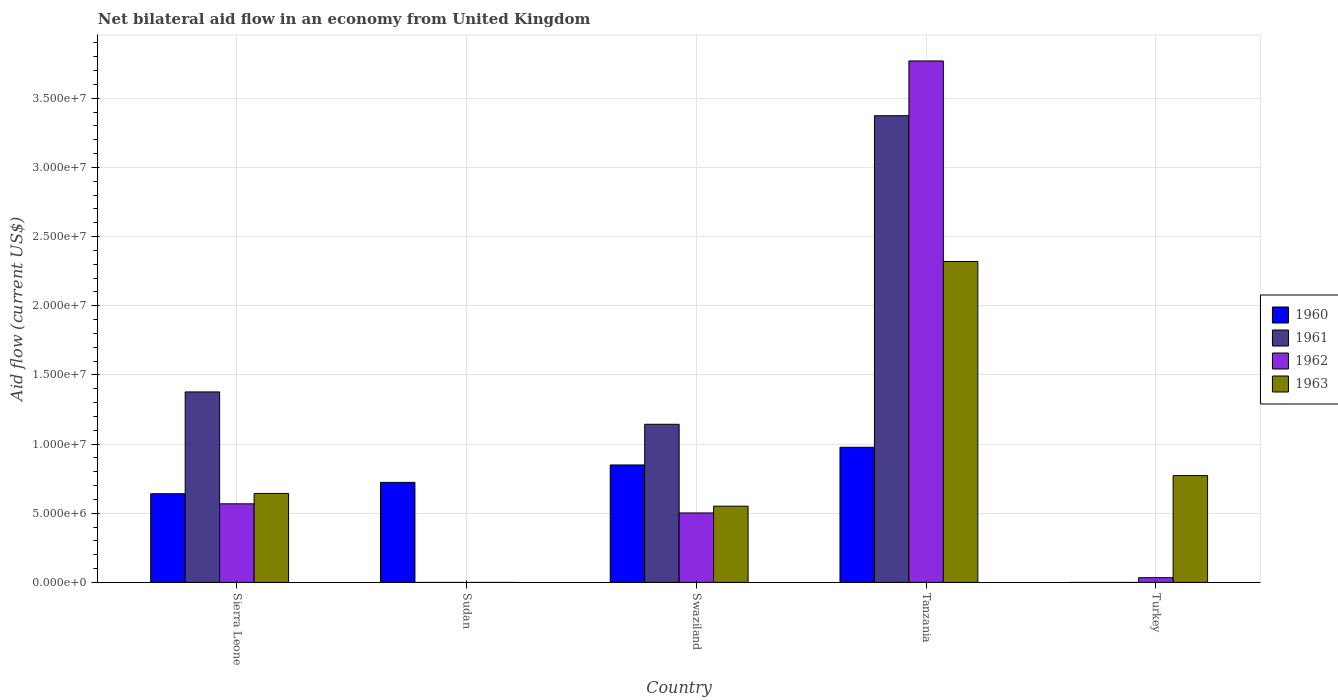How many different coloured bars are there?
Provide a short and direct response. 4. Are the number of bars per tick equal to the number of legend labels?
Keep it short and to the point. No. What is the label of the 1st group of bars from the left?
Your response must be concise. Sierra Leone. In how many cases, is the number of bars for a given country not equal to the number of legend labels?
Provide a succinct answer. 2. What is the net bilateral aid flow in 1962 in Sierra Leone?
Offer a very short reply. 5.68e+06. Across all countries, what is the maximum net bilateral aid flow in 1961?
Keep it short and to the point. 3.37e+07. In which country was the net bilateral aid flow in 1962 maximum?
Offer a very short reply. Tanzania. What is the total net bilateral aid flow in 1961 in the graph?
Your answer should be compact. 5.89e+07. What is the difference between the net bilateral aid flow in 1960 in Sierra Leone and that in Tanzania?
Make the answer very short. -3.36e+06. What is the difference between the net bilateral aid flow in 1960 in Sudan and the net bilateral aid flow in 1963 in Turkey?
Offer a terse response. -4.90e+05. What is the average net bilateral aid flow in 1960 per country?
Provide a succinct answer. 6.38e+06. What is the difference between the net bilateral aid flow of/in 1960 and net bilateral aid flow of/in 1962 in Tanzania?
Offer a terse response. -2.79e+07. In how many countries, is the net bilateral aid flow in 1960 greater than 37000000 US$?
Your response must be concise. 0. What is the ratio of the net bilateral aid flow in 1963 in Swaziland to that in Turkey?
Your response must be concise. 0.71. What is the difference between the highest and the second highest net bilateral aid flow in 1963?
Your answer should be compact. 1.68e+07. What is the difference between the highest and the lowest net bilateral aid flow in 1963?
Your response must be concise. 2.32e+07. Is the sum of the net bilateral aid flow in 1963 in Swaziland and Turkey greater than the maximum net bilateral aid flow in 1961 across all countries?
Offer a very short reply. No. How many bars are there?
Your answer should be very brief. 15. How many countries are there in the graph?
Your answer should be very brief. 5. What is the difference between two consecutive major ticks on the Y-axis?
Your response must be concise. 5.00e+06. Does the graph contain any zero values?
Keep it short and to the point. Yes. Does the graph contain grids?
Provide a succinct answer. Yes. Where does the legend appear in the graph?
Offer a very short reply. Center right. What is the title of the graph?
Your answer should be very brief. Net bilateral aid flow in an economy from United Kingdom. What is the Aid flow (current US$) of 1960 in Sierra Leone?
Provide a succinct answer. 6.41e+06. What is the Aid flow (current US$) of 1961 in Sierra Leone?
Offer a terse response. 1.38e+07. What is the Aid flow (current US$) of 1962 in Sierra Leone?
Make the answer very short. 5.68e+06. What is the Aid flow (current US$) in 1963 in Sierra Leone?
Keep it short and to the point. 6.43e+06. What is the Aid flow (current US$) in 1960 in Sudan?
Provide a short and direct response. 7.23e+06. What is the Aid flow (current US$) of 1961 in Sudan?
Provide a short and direct response. 0. What is the Aid flow (current US$) of 1963 in Sudan?
Make the answer very short. 0. What is the Aid flow (current US$) of 1960 in Swaziland?
Offer a very short reply. 8.49e+06. What is the Aid flow (current US$) of 1961 in Swaziland?
Your response must be concise. 1.14e+07. What is the Aid flow (current US$) of 1962 in Swaziland?
Provide a succinct answer. 5.02e+06. What is the Aid flow (current US$) in 1963 in Swaziland?
Give a very brief answer. 5.51e+06. What is the Aid flow (current US$) in 1960 in Tanzania?
Make the answer very short. 9.77e+06. What is the Aid flow (current US$) in 1961 in Tanzania?
Offer a terse response. 3.37e+07. What is the Aid flow (current US$) in 1962 in Tanzania?
Keep it short and to the point. 3.77e+07. What is the Aid flow (current US$) of 1963 in Tanzania?
Give a very brief answer. 2.32e+07. What is the Aid flow (current US$) of 1960 in Turkey?
Give a very brief answer. 0. What is the Aid flow (current US$) of 1961 in Turkey?
Provide a short and direct response. 0. What is the Aid flow (current US$) in 1962 in Turkey?
Keep it short and to the point. 3.40e+05. What is the Aid flow (current US$) in 1963 in Turkey?
Offer a very short reply. 7.72e+06. Across all countries, what is the maximum Aid flow (current US$) of 1960?
Give a very brief answer. 9.77e+06. Across all countries, what is the maximum Aid flow (current US$) of 1961?
Your response must be concise. 3.37e+07. Across all countries, what is the maximum Aid flow (current US$) of 1962?
Your response must be concise. 3.77e+07. Across all countries, what is the maximum Aid flow (current US$) in 1963?
Make the answer very short. 2.32e+07. Across all countries, what is the minimum Aid flow (current US$) of 1960?
Provide a succinct answer. 0. Across all countries, what is the minimum Aid flow (current US$) of 1961?
Your answer should be compact. 0. Across all countries, what is the minimum Aid flow (current US$) in 1962?
Provide a succinct answer. 0. Across all countries, what is the minimum Aid flow (current US$) in 1963?
Offer a very short reply. 0. What is the total Aid flow (current US$) in 1960 in the graph?
Ensure brevity in your answer.  3.19e+07. What is the total Aid flow (current US$) in 1961 in the graph?
Your answer should be compact. 5.89e+07. What is the total Aid flow (current US$) in 1962 in the graph?
Provide a succinct answer. 4.87e+07. What is the total Aid flow (current US$) in 1963 in the graph?
Offer a terse response. 4.29e+07. What is the difference between the Aid flow (current US$) of 1960 in Sierra Leone and that in Sudan?
Give a very brief answer. -8.20e+05. What is the difference between the Aid flow (current US$) of 1960 in Sierra Leone and that in Swaziland?
Offer a terse response. -2.08e+06. What is the difference between the Aid flow (current US$) of 1961 in Sierra Leone and that in Swaziland?
Your response must be concise. 2.34e+06. What is the difference between the Aid flow (current US$) in 1963 in Sierra Leone and that in Swaziland?
Keep it short and to the point. 9.20e+05. What is the difference between the Aid flow (current US$) of 1960 in Sierra Leone and that in Tanzania?
Offer a very short reply. -3.36e+06. What is the difference between the Aid flow (current US$) of 1961 in Sierra Leone and that in Tanzania?
Your answer should be very brief. -2.00e+07. What is the difference between the Aid flow (current US$) of 1962 in Sierra Leone and that in Tanzania?
Give a very brief answer. -3.20e+07. What is the difference between the Aid flow (current US$) of 1963 in Sierra Leone and that in Tanzania?
Provide a succinct answer. -1.68e+07. What is the difference between the Aid flow (current US$) in 1962 in Sierra Leone and that in Turkey?
Your answer should be very brief. 5.34e+06. What is the difference between the Aid flow (current US$) in 1963 in Sierra Leone and that in Turkey?
Your answer should be very brief. -1.29e+06. What is the difference between the Aid flow (current US$) of 1960 in Sudan and that in Swaziland?
Your response must be concise. -1.26e+06. What is the difference between the Aid flow (current US$) in 1960 in Sudan and that in Tanzania?
Your answer should be compact. -2.54e+06. What is the difference between the Aid flow (current US$) in 1960 in Swaziland and that in Tanzania?
Make the answer very short. -1.28e+06. What is the difference between the Aid flow (current US$) in 1961 in Swaziland and that in Tanzania?
Keep it short and to the point. -2.23e+07. What is the difference between the Aid flow (current US$) of 1962 in Swaziland and that in Tanzania?
Give a very brief answer. -3.27e+07. What is the difference between the Aid flow (current US$) in 1963 in Swaziland and that in Tanzania?
Provide a short and direct response. -1.77e+07. What is the difference between the Aid flow (current US$) of 1962 in Swaziland and that in Turkey?
Offer a very short reply. 4.68e+06. What is the difference between the Aid flow (current US$) in 1963 in Swaziland and that in Turkey?
Ensure brevity in your answer.  -2.21e+06. What is the difference between the Aid flow (current US$) in 1962 in Tanzania and that in Turkey?
Keep it short and to the point. 3.74e+07. What is the difference between the Aid flow (current US$) in 1963 in Tanzania and that in Turkey?
Your answer should be very brief. 1.55e+07. What is the difference between the Aid flow (current US$) in 1960 in Sierra Leone and the Aid flow (current US$) in 1961 in Swaziland?
Offer a very short reply. -5.02e+06. What is the difference between the Aid flow (current US$) in 1960 in Sierra Leone and the Aid flow (current US$) in 1962 in Swaziland?
Give a very brief answer. 1.39e+06. What is the difference between the Aid flow (current US$) in 1960 in Sierra Leone and the Aid flow (current US$) in 1963 in Swaziland?
Keep it short and to the point. 9.00e+05. What is the difference between the Aid flow (current US$) of 1961 in Sierra Leone and the Aid flow (current US$) of 1962 in Swaziland?
Provide a succinct answer. 8.75e+06. What is the difference between the Aid flow (current US$) in 1961 in Sierra Leone and the Aid flow (current US$) in 1963 in Swaziland?
Give a very brief answer. 8.26e+06. What is the difference between the Aid flow (current US$) in 1962 in Sierra Leone and the Aid flow (current US$) in 1963 in Swaziland?
Offer a terse response. 1.70e+05. What is the difference between the Aid flow (current US$) of 1960 in Sierra Leone and the Aid flow (current US$) of 1961 in Tanzania?
Your answer should be compact. -2.73e+07. What is the difference between the Aid flow (current US$) in 1960 in Sierra Leone and the Aid flow (current US$) in 1962 in Tanzania?
Make the answer very short. -3.13e+07. What is the difference between the Aid flow (current US$) in 1960 in Sierra Leone and the Aid flow (current US$) in 1963 in Tanzania?
Offer a terse response. -1.68e+07. What is the difference between the Aid flow (current US$) in 1961 in Sierra Leone and the Aid flow (current US$) in 1962 in Tanzania?
Give a very brief answer. -2.39e+07. What is the difference between the Aid flow (current US$) of 1961 in Sierra Leone and the Aid flow (current US$) of 1963 in Tanzania?
Your answer should be compact. -9.43e+06. What is the difference between the Aid flow (current US$) in 1962 in Sierra Leone and the Aid flow (current US$) in 1963 in Tanzania?
Your answer should be very brief. -1.75e+07. What is the difference between the Aid flow (current US$) in 1960 in Sierra Leone and the Aid flow (current US$) in 1962 in Turkey?
Keep it short and to the point. 6.07e+06. What is the difference between the Aid flow (current US$) of 1960 in Sierra Leone and the Aid flow (current US$) of 1963 in Turkey?
Keep it short and to the point. -1.31e+06. What is the difference between the Aid flow (current US$) in 1961 in Sierra Leone and the Aid flow (current US$) in 1962 in Turkey?
Your response must be concise. 1.34e+07. What is the difference between the Aid flow (current US$) in 1961 in Sierra Leone and the Aid flow (current US$) in 1963 in Turkey?
Offer a terse response. 6.05e+06. What is the difference between the Aid flow (current US$) in 1962 in Sierra Leone and the Aid flow (current US$) in 1963 in Turkey?
Give a very brief answer. -2.04e+06. What is the difference between the Aid flow (current US$) in 1960 in Sudan and the Aid flow (current US$) in 1961 in Swaziland?
Provide a short and direct response. -4.20e+06. What is the difference between the Aid flow (current US$) in 1960 in Sudan and the Aid flow (current US$) in 1962 in Swaziland?
Your response must be concise. 2.21e+06. What is the difference between the Aid flow (current US$) of 1960 in Sudan and the Aid flow (current US$) of 1963 in Swaziland?
Your response must be concise. 1.72e+06. What is the difference between the Aid flow (current US$) of 1960 in Sudan and the Aid flow (current US$) of 1961 in Tanzania?
Provide a short and direct response. -2.65e+07. What is the difference between the Aid flow (current US$) of 1960 in Sudan and the Aid flow (current US$) of 1962 in Tanzania?
Your answer should be compact. -3.05e+07. What is the difference between the Aid flow (current US$) of 1960 in Sudan and the Aid flow (current US$) of 1963 in Tanzania?
Give a very brief answer. -1.60e+07. What is the difference between the Aid flow (current US$) in 1960 in Sudan and the Aid flow (current US$) in 1962 in Turkey?
Offer a terse response. 6.89e+06. What is the difference between the Aid flow (current US$) in 1960 in Sudan and the Aid flow (current US$) in 1963 in Turkey?
Provide a succinct answer. -4.90e+05. What is the difference between the Aid flow (current US$) of 1960 in Swaziland and the Aid flow (current US$) of 1961 in Tanzania?
Offer a very short reply. -2.52e+07. What is the difference between the Aid flow (current US$) in 1960 in Swaziland and the Aid flow (current US$) in 1962 in Tanzania?
Make the answer very short. -2.92e+07. What is the difference between the Aid flow (current US$) of 1960 in Swaziland and the Aid flow (current US$) of 1963 in Tanzania?
Your answer should be compact. -1.47e+07. What is the difference between the Aid flow (current US$) in 1961 in Swaziland and the Aid flow (current US$) in 1962 in Tanzania?
Your answer should be very brief. -2.63e+07. What is the difference between the Aid flow (current US$) of 1961 in Swaziland and the Aid flow (current US$) of 1963 in Tanzania?
Ensure brevity in your answer.  -1.18e+07. What is the difference between the Aid flow (current US$) in 1962 in Swaziland and the Aid flow (current US$) in 1963 in Tanzania?
Your answer should be very brief. -1.82e+07. What is the difference between the Aid flow (current US$) in 1960 in Swaziland and the Aid flow (current US$) in 1962 in Turkey?
Your answer should be very brief. 8.15e+06. What is the difference between the Aid flow (current US$) in 1960 in Swaziland and the Aid flow (current US$) in 1963 in Turkey?
Give a very brief answer. 7.70e+05. What is the difference between the Aid flow (current US$) of 1961 in Swaziland and the Aid flow (current US$) of 1962 in Turkey?
Your response must be concise. 1.11e+07. What is the difference between the Aid flow (current US$) in 1961 in Swaziland and the Aid flow (current US$) in 1963 in Turkey?
Keep it short and to the point. 3.71e+06. What is the difference between the Aid flow (current US$) in 1962 in Swaziland and the Aid flow (current US$) in 1963 in Turkey?
Make the answer very short. -2.70e+06. What is the difference between the Aid flow (current US$) in 1960 in Tanzania and the Aid flow (current US$) in 1962 in Turkey?
Provide a succinct answer. 9.43e+06. What is the difference between the Aid flow (current US$) of 1960 in Tanzania and the Aid flow (current US$) of 1963 in Turkey?
Give a very brief answer. 2.05e+06. What is the difference between the Aid flow (current US$) in 1961 in Tanzania and the Aid flow (current US$) in 1962 in Turkey?
Your answer should be very brief. 3.34e+07. What is the difference between the Aid flow (current US$) of 1961 in Tanzania and the Aid flow (current US$) of 1963 in Turkey?
Keep it short and to the point. 2.60e+07. What is the difference between the Aid flow (current US$) in 1962 in Tanzania and the Aid flow (current US$) in 1963 in Turkey?
Your response must be concise. 3.00e+07. What is the average Aid flow (current US$) of 1960 per country?
Your response must be concise. 6.38e+06. What is the average Aid flow (current US$) in 1961 per country?
Your answer should be compact. 1.18e+07. What is the average Aid flow (current US$) in 1962 per country?
Offer a terse response. 9.75e+06. What is the average Aid flow (current US$) in 1963 per country?
Your answer should be compact. 8.57e+06. What is the difference between the Aid flow (current US$) of 1960 and Aid flow (current US$) of 1961 in Sierra Leone?
Make the answer very short. -7.36e+06. What is the difference between the Aid flow (current US$) of 1960 and Aid flow (current US$) of 1962 in Sierra Leone?
Give a very brief answer. 7.30e+05. What is the difference between the Aid flow (current US$) of 1961 and Aid flow (current US$) of 1962 in Sierra Leone?
Your answer should be compact. 8.09e+06. What is the difference between the Aid flow (current US$) in 1961 and Aid flow (current US$) in 1963 in Sierra Leone?
Make the answer very short. 7.34e+06. What is the difference between the Aid flow (current US$) in 1962 and Aid flow (current US$) in 1963 in Sierra Leone?
Offer a very short reply. -7.50e+05. What is the difference between the Aid flow (current US$) in 1960 and Aid flow (current US$) in 1961 in Swaziland?
Your answer should be compact. -2.94e+06. What is the difference between the Aid flow (current US$) of 1960 and Aid flow (current US$) of 1962 in Swaziland?
Make the answer very short. 3.47e+06. What is the difference between the Aid flow (current US$) in 1960 and Aid flow (current US$) in 1963 in Swaziland?
Give a very brief answer. 2.98e+06. What is the difference between the Aid flow (current US$) of 1961 and Aid flow (current US$) of 1962 in Swaziland?
Provide a short and direct response. 6.41e+06. What is the difference between the Aid flow (current US$) in 1961 and Aid flow (current US$) in 1963 in Swaziland?
Ensure brevity in your answer.  5.92e+06. What is the difference between the Aid flow (current US$) in 1962 and Aid flow (current US$) in 1963 in Swaziland?
Give a very brief answer. -4.90e+05. What is the difference between the Aid flow (current US$) of 1960 and Aid flow (current US$) of 1961 in Tanzania?
Your answer should be very brief. -2.40e+07. What is the difference between the Aid flow (current US$) in 1960 and Aid flow (current US$) in 1962 in Tanzania?
Your response must be concise. -2.79e+07. What is the difference between the Aid flow (current US$) in 1960 and Aid flow (current US$) in 1963 in Tanzania?
Make the answer very short. -1.34e+07. What is the difference between the Aid flow (current US$) in 1961 and Aid flow (current US$) in 1962 in Tanzania?
Give a very brief answer. -3.96e+06. What is the difference between the Aid flow (current US$) in 1961 and Aid flow (current US$) in 1963 in Tanzania?
Your answer should be very brief. 1.05e+07. What is the difference between the Aid flow (current US$) in 1962 and Aid flow (current US$) in 1963 in Tanzania?
Provide a succinct answer. 1.45e+07. What is the difference between the Aid flow (current US$) of 1962 and Aid flow (current US$) of 1963 in Turkey?
Keep it short and to the point. -7.38e+06. What is the ratio of the Aid flow (current US$) in 1960 in Sierra Leone to that in Sudan?
Offer a very short reply. 0.89. What is the ratio of the Aid flow (current US$) in 1960 in Sierra Leone to that in Swaziland?
Offer a terse response. 0.76. What is the ratio of the Aid flow (current US$) in 1961 in Sierra Leone to that in Swaziland?
Keep it short and to the point. 1.2. What is the ratio of the Aid flow (current US$) of 1962 in Sierra Leone to that in Swaziland?
Offer a terse response. 1.13. What is the ratio of the Aid flow (current US$) in 1963 in Sierra Leone to that in Swaziland?
Your response must be concise. 1.17. What is the ratio of the Aid flow (current US$) in 1960 in Sierra Leone to that in Tanzania?
Offer a terse response. 0.66. What is the ratio of the Aid flow (current US$) of 1961 in Sierra Leone to that in Tanzania?
Keep it short and to the point. 0.41. What is the ratio of the Aid flow (current US$) in 1962 in Sierra Leone to that in Tanzania?
Make the answer very short. 0.15. What is the ratio of the Aid flow (current US$) in 1963 in Sierra Leone to that in Tanzania?
Your response must be concise. 0.28. What is the ratio of the Aid flow (current US$) of 1962 in Sierra Leone to that in Turkey?
Your response must be concise. 16.71. What is the ratio of the Aid flow (current US$) of 1963 in Sierra Leone to that in Turkey?
Provide a short and direct response. 0.83. What is the ratio of the Aid flow (current US$) in 1960 in Sudan to that in Swaziland?
Make the answer very short. 0.85. What is the ratio of the Aid flow (current US$) in 1960 in Sudan to that in Tanzania?
Give a very brief answer. 0.74. What is the ratio of the Aid flow (current US$) in 1960 in Swaziland to that in Tanzania?
Provide a succinct answer. 0.87. What is the ratio of the Aid flow (current US$) in 1961 in Swaziland to that in Tanzania?
Provide a succinct answer. 0.34. What is the ratio of the Aid flow (current US$) of 1962 in Swaziland to that in Tanzania?
Your answer should be compact. 0.13. What is the ratio of the Aid flow (current US$) in 1963 in Swaziland to that in Tanzania?
Your response must be concise. 0.24. What is the ratio of the Aid flow (current US$) in 1962 in Swaziland to that in Turkey?
Offer a terse response. 14.76. What is the ratio of the Aid flow (current US$) of 1963 in Swaziland to that in Turkey?
Offer a very short reply. 0.71. What is the ratio of the Aid flow (current US$) in 1962 in Tanzania to that in Turkey?
Offer a very short reply. 110.88. What is the ratio of the Aid flow (current US$) of 1963 in Tanzania to that in Turkey?
Give a very brief answer. 3.01. What is the difference between the highest and the second highest Aid flow (current US$) in 1960?
Your answer should be very brief. 1.28e+06. What is the difference between the highest and the second highest Aid flow (current US$) of 1961?
Your response must be concise. 2.00e+07. What is the difference between the highest and the second highest Aid flow (current US$) of 1962?
Your response must be concise. 3.20e+07. What is the difference between the highest and the second highest Aid flow (current US$) of 1963?
Your answer should be compact. 1.55e+07. What is the difference between the highest and the lowest Aid flow (current US$) of 1960?
Your response must be concise. 9.77e+06. What is the difference between the highest and the lowest Aid flow (current US$) in 1961?
Provide a succinct answer. 3.37e+07. What is the difference between the highest and the lowest Aid flow (current US$) of 1962?
Provide a short and direct response. 3.77e+07. What is the difference between the highest and the lowest Aid flow (current US$) in 1963?
Give a very brief answer. 2.32e+07. 